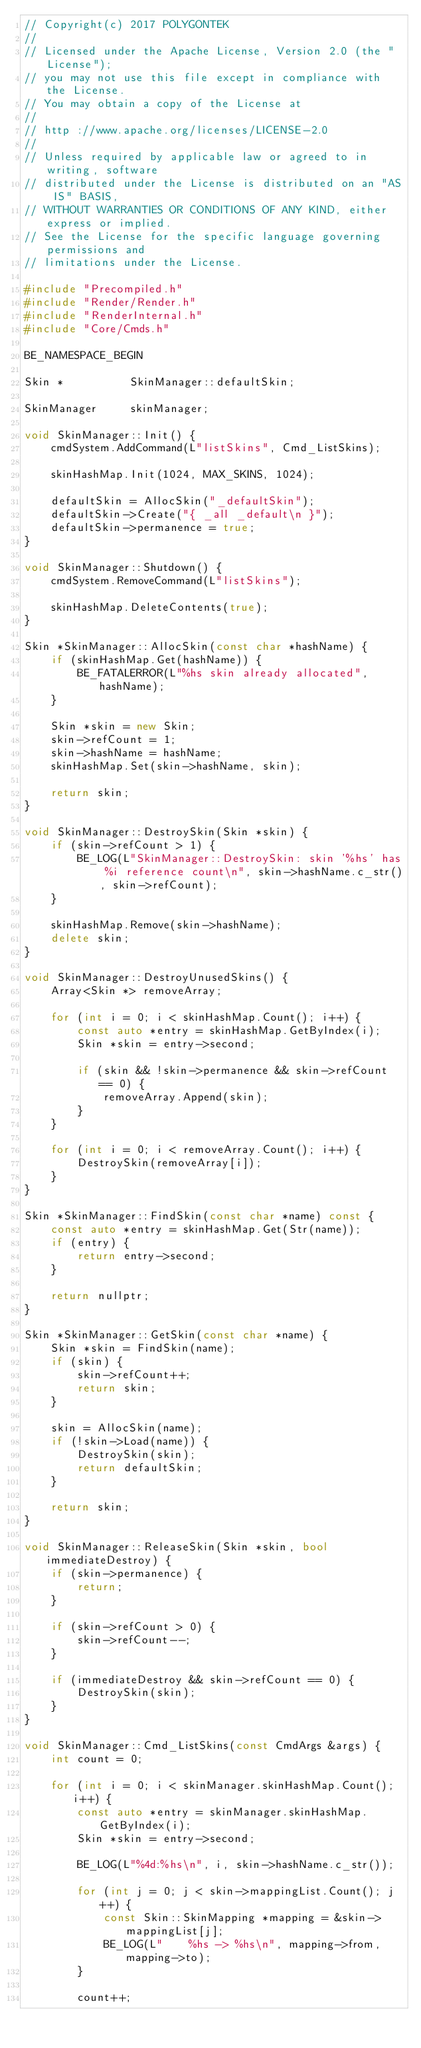Convert code to text. <code><loc_0><loc_0><loc_500><loc_500><_C++_>// Copyright(c) 2017 POLYGONTEK
// 
// Licensed under the Apache License, Version 2.0 (the "License");
// you may not use this file except in compliance with the License.
// You may obtain a copy of the License at
// 
// http ://www.apache.org/licenses/LICENSE-2.0
// 
// Unless required by applicable law or agreed to in writing, software
// distributed under the License is distributed on an "AS IS" BASIS,
// WITHOUT WARRANTIES OR CONDITIONS OF ANY KIND, either express or implied.
// See the License for the specific language governing permissions and
// limitations under the License.

#include "Precompiled.h"
#include "Render/Render.h"
#include "RenderInternal.h"
#include "Core/Cmds.h"

BE_NAMESPACE_BEGIN

Skin *          SkinManager::defaultSkin;

SkinManager     skinManager;

void SkinManager::Init() {
    cmdSystem.AddCommand(L"listSkins", Cmd_ListSkins);

    skinHashMap.Init(1024, MAX_SKINS, 1024);

    defaultSkin = AllocSkin("_defaultSkin");
    defaultSkin->Create("{ _all _default\n }");
    defaultSkin->permanence = true;
}

void SkinManager::Shutdown() {
    cmdSystem.RemoveCommand(L"listSkins");

    skinHashMap.DeleteContents(true);
}

Skin *SkinManager::AllocSkin(const char *hashName) {
    if (skinHashMap.Get(hashName)) {
        BE_FATALERROR(L"%hs skin already allocated", hashName);
    }
    
    Skin *skin = new Skin;
    skin->refCount = 1;
    skin->hashName = hashName;
    skinHashMap.Set(skin->hashName, skin);
            
    return skin;
}

void SkinManager::DestroySkin(Skin *skin) {
    if (skin->refCount > 1) {
        BE_LOG(L"SkinManager::DestroySkin: skin '%hs' has %i reference count\n", skin->hashName.c_str(), skin->refCount);
    }

    skinHashMap.Remove(skin->hashName);
    delete skin;
}

void SkinManager::DestroyUnusedSkins() {
    Array<Skin *> removeArray;

    for (int i = 0; i < skinHashMap.Count(); i++) {
        const auto *entry = skinHashMap.GetByIndex(i);
        Skin *skin = entry->second;

        if (skin && !skin->permanence && skin->refCount == 0) {
            removeArray.Append(skin);
        }
    }

    for (int i = 0; i < removeArray.Count(); i++) {
        DestroySkin(removeArray[i]);
    }
}

Skin *SkinManager::FindSkin(const char *name) const {
    const auto *entry = skinHashMap.Get(Str(name));
    if (entry) {
        return entry->second;
    }
    
    return nullptr;
}

Skin *SkinManager::GetSkin(const char *name) {
    Skin *skin = FindSkin(name);
    if (skin) {
        skin->refCount++;
        return skin;
    }

    skin = AllocSkin(name);
    if (!skin->Load(name)) {
        DestroySkin(skin);
        return defaultSkin;
    }

    return skin;
}

void SkinManager::ReleaseSkin(Skin *skin, bool immediateDestroy) {
    if (skin->permanence) {
        return;
    }

    if (skin->refCount > 0) {
        skin->refCount--;
    }

    if (immediateDestroy && skin->refCount == 0) {
        DestroySkin(skin);
    }
}

void SkinManager::Cmd_ListSkins(const CmdArgs &args) {
    int count = 0;

    for (int i = 0; i < skinManager.skinHashMap.Count(); i++) {
        const auto *entry = skinManager.skinHashMap.GetByIndex(i);
        Skin *skin = entry->second;

        BE_LOG(L"%4d:%hs\n", i, skin->hashName.c_str());

        for (int j = 0; j < skin->mappingList.Count(); j++) {
            const Skin::SkinMapping *mapping = &skin->mappingList[j];
            BE_LOG(L"    %hs -> %hs\n", mapping->from, mapping->to);
        }

        count++;</code> 